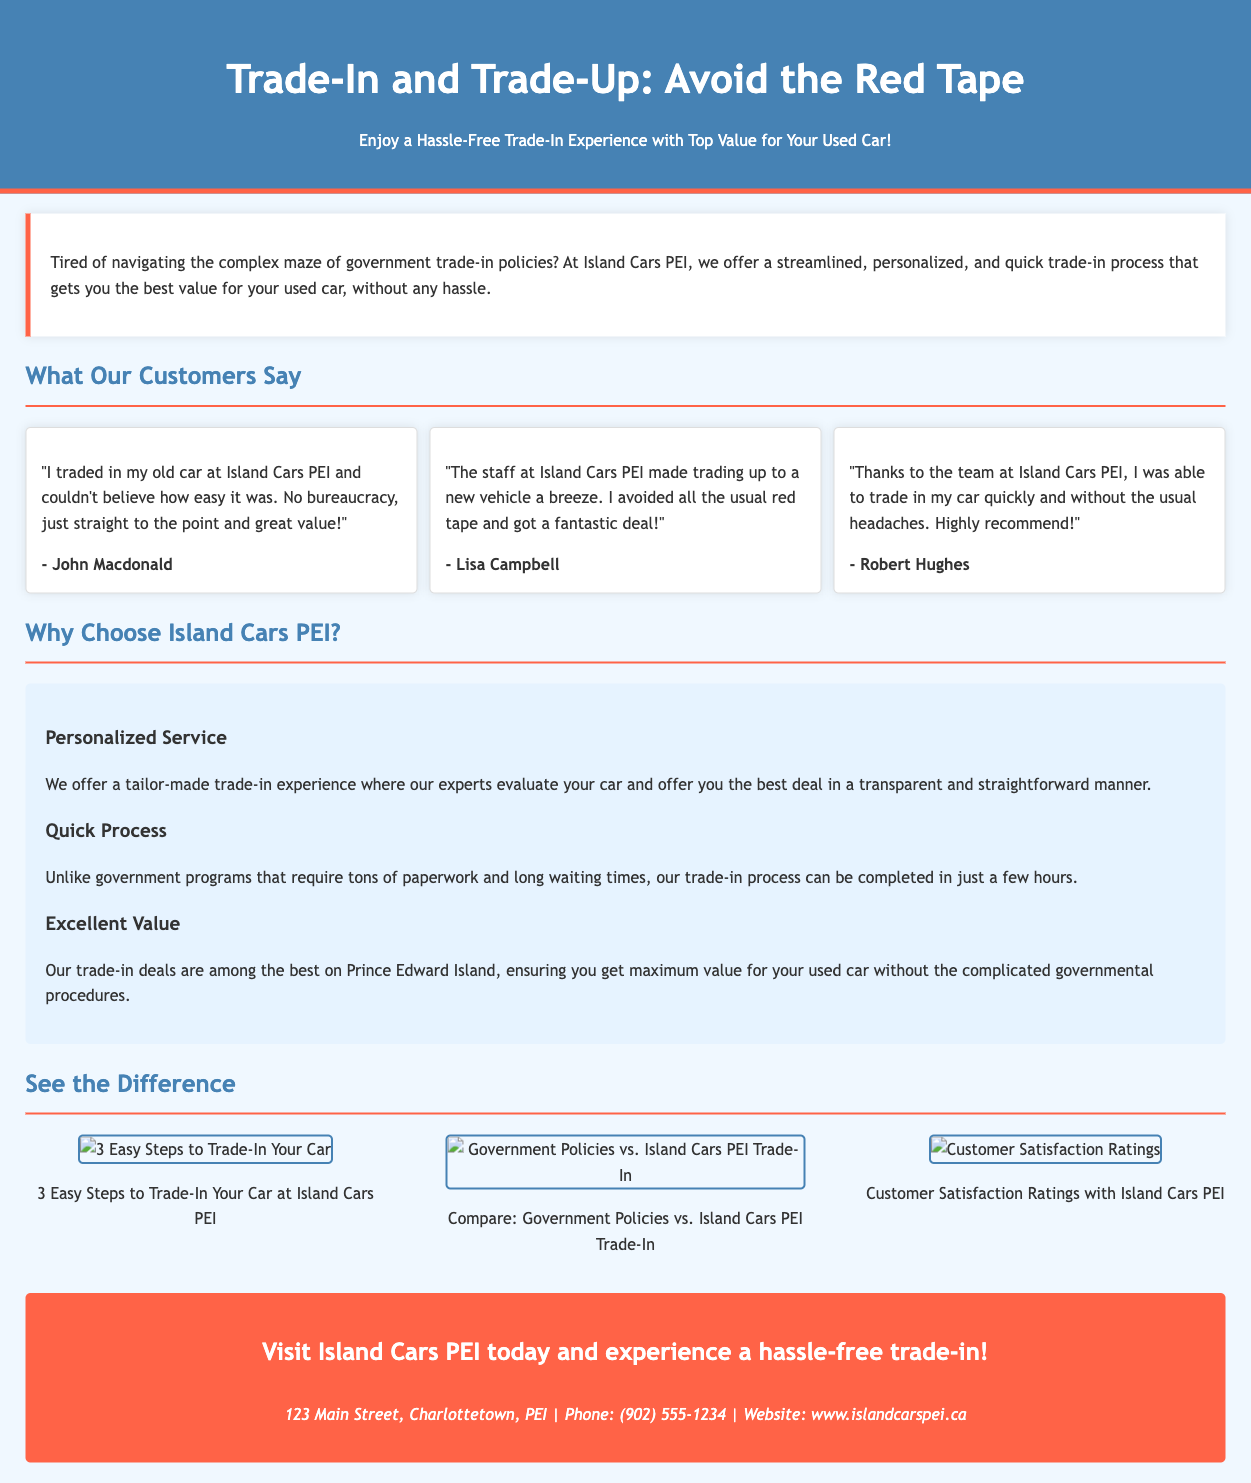What is the title of the advertisement? The title of the advertisement is prominently displayed at the top of the document.
Answer: Trade-In and Trade-Up: Avoid the Red Tape What is the background color of the headers? The background color of the headers is specified in the style section and enhances visual appeal.
Answer: #4682b4 Who is quoted as saying trading in was "easy"? This testimonial reflects customer satisfaction and highlights a key benefit of the service provided.
Answer: John Macdonald How many testimonials are featured in the advertisement? The document contains references to customer experiences, representing feedback collected from several clients.
Answer: 3 What are the three easy steps depicted in the infographics? The infographics section breaks down the process into simple, manageable steps for clarity and understanding.
Answer: Not specified in the text What is one key advantage of trading in at Island Cars PEI? This question focuses on identifying unique selling points emphasized in the advertisement.
Answer: Excellent Value What is the contact phone number provided? The contact information assists potential customers in reaching out for further inquiries or to initiate trade-ins.
Answer: (902) 555-1234 Where is Island Cars PEI located? The location information is essential for customers wanting to visit the dealership.
Answer: 123 Main Street, Charlottetown, PEI What color is the call-to-action section? The specific color coding used in the advertisement helps differentiate the sections visually.
Answer: #ff6347 